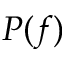<formula> <loc_0><loc_0><loc_500><loc_500>P ( f )</formula> 